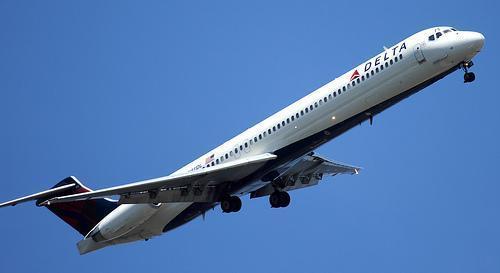How many airplanes are flying?
Give a very brief answer. 1. 